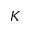<formula> <loc_0><loc_0><loc_500><loc_500>K</formula> 